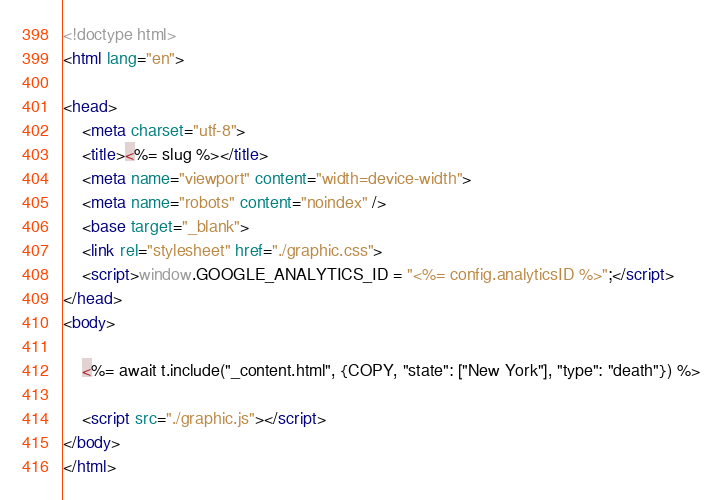Convert code to text. <code><loc_0><loc_0><loc_500><loc_500><_HTML_><!doctype html>
<html lang="en">

<head>
    <meta charset="utf-8">
    <title><%= slug %></title>
    <meta name="viewport" content="width=device-width">
    <meta name="robots" content="noindex" />
    <base target="_blank">
    <link rel="stylesheet" href="./graphic.css">
    <script>window.GOOGLE_ANALYTICS_ID = "<%= config.analyticsID %>";</script>
</head>
<body>

    <%= await t.include("_content.html", {COPY, "state": ["New York"], "type": "death"}) %>

    <script src="./graphic.js"></script>
</body>
</html>
</code> 